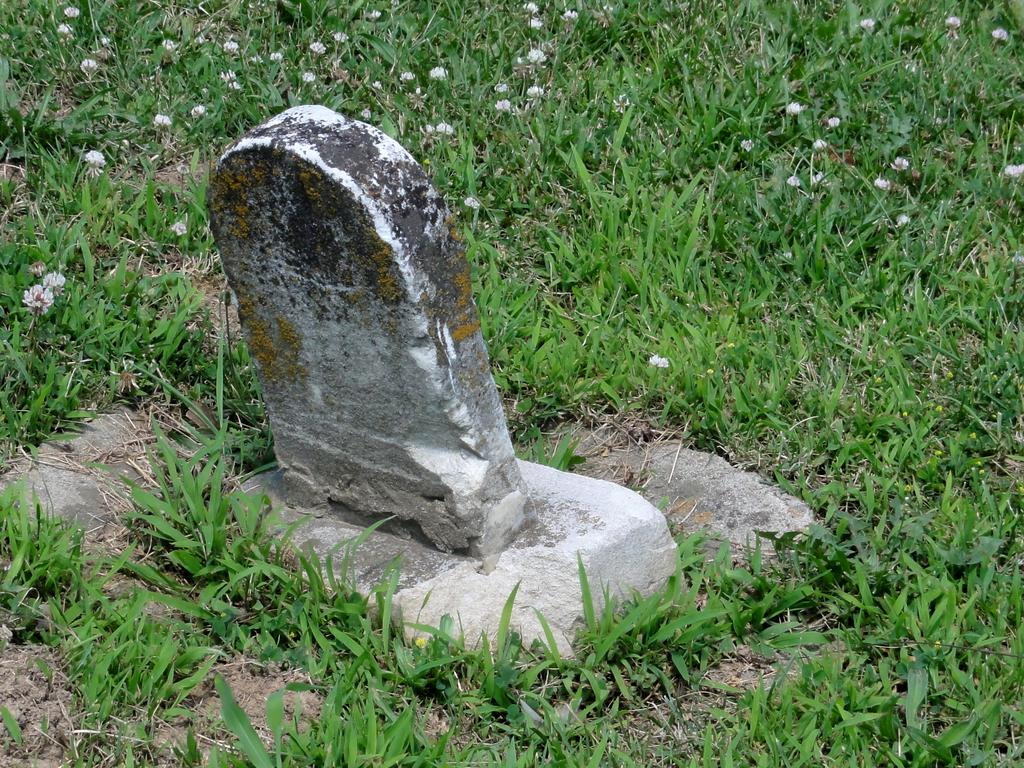What type of vegetation is present on the ground in the image? There is grass on the ground in the image. What can be found in the center of the grass? There is a stone in the center of the grass. What other elements are present on the grass? There are flowers on the grass. What is the color of the flowers? The flowers are white in color. Can you hear the thunder in the image? There is no mention of thunder or any sound in the image, so it cannot be heard. What type of badge is visible on the flowers? There is no badge present in the image; it only features grass, a stone, and white flowers. 